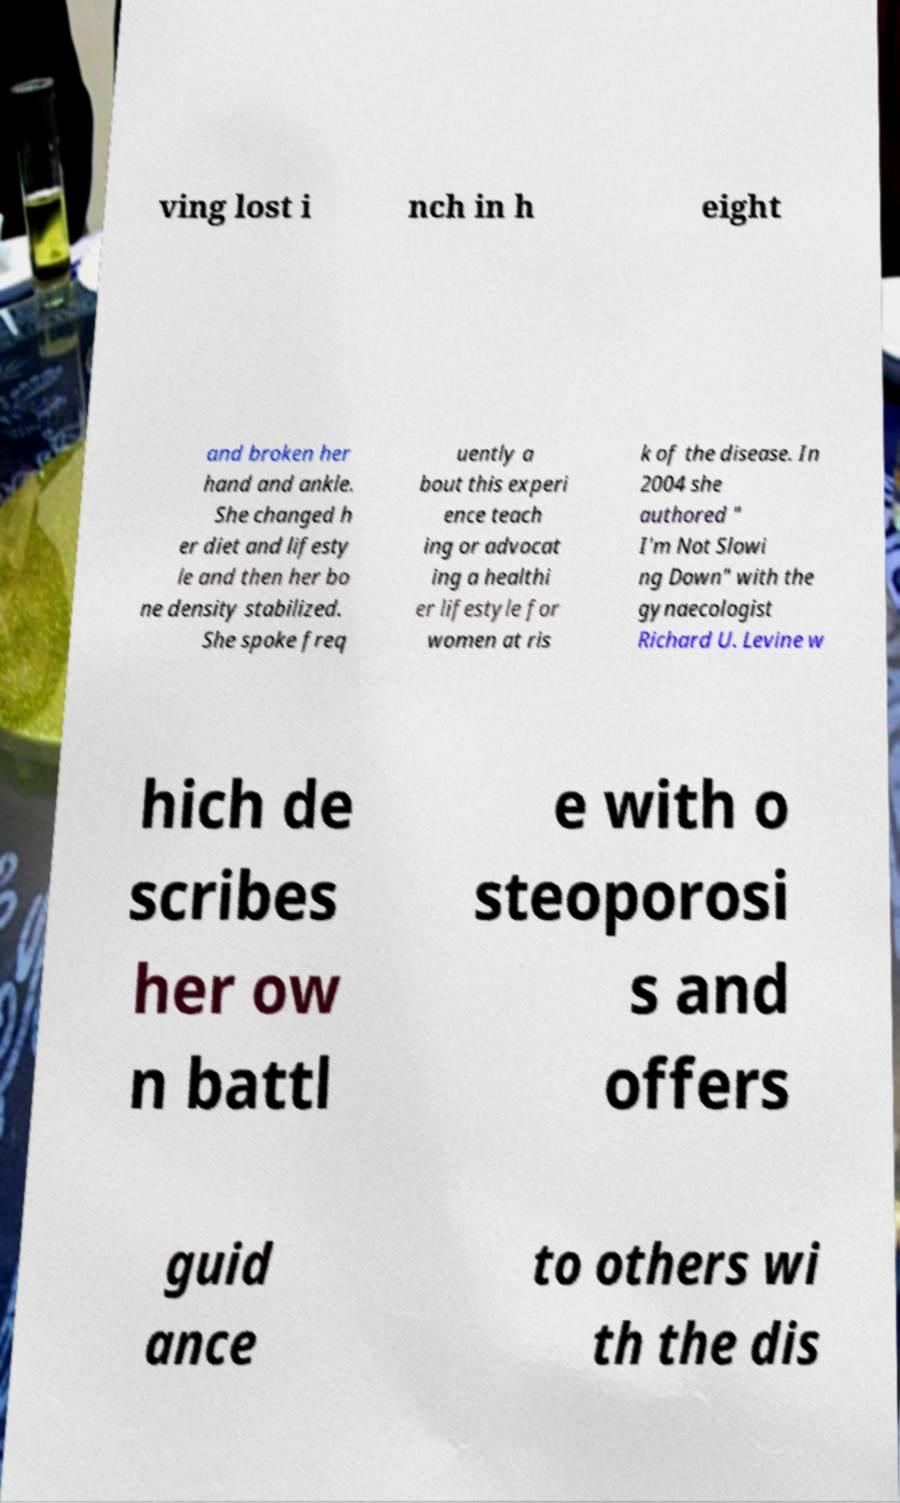There's text embedded in this image that I need extracted. Can you transcribe it verbatim? ving lost i nch in h eight and broken her hand and ankle. She changed h er diet and lifesty le and then her bo ne density stabilized. She spoke freq uently a bout this experi ence teach ing or advocat ing a healthi er lifestyle for women at ris k of the disease. In 2004 she authored " I'm Not Slowi ng Down" with the gynaecologist Richard U. Levine w hich de scribes her ow n battl e with o steoporosi s and offers guid ance to others wi th the dis 